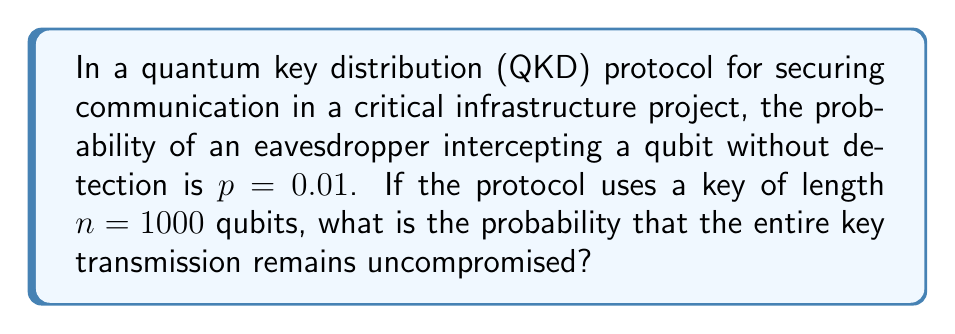What is the answer to this math problem? To solve this problem, we need to follow these steps:

1) In QKD, each qubit is independently transmitted. For the entire key to remain uncompromised, every single qubit must be transmitted without interception.

2) The probability of a single qubit being transmitted without interception is the complement of the probability of interception:

   $P(\text{qubit not intercepted}) = 1 - p = 1 - 0.01 = 0.99$

3) For the entire key to be uncompromised, all $n$ qubits must be transmitted without interception. Since these are independent events, we multiply the probabilities:

   $P(\text{key uncompromised}) = (0.99)^n$

4) We're given that $n = 1000$, so we substitute this value:

   $P(\text{key uncompromised}) = (0.99)^{1000}$

5) To calculate this, we can use the properties of exponents:

   $(0.99)^{1000} = e^{1000 \ln(0.99)}$

6) Using a calculator or computer:

   $e^{1000 \ln(0.99)} \approx 4.317 \times 10^{-5}$

This extremely low probability demonstrates the high security of QKD protocols, even when individual qubit interceptions have a relatively high probability of going undetected.
Answer: $4.317 \times 10^{-5}$ 